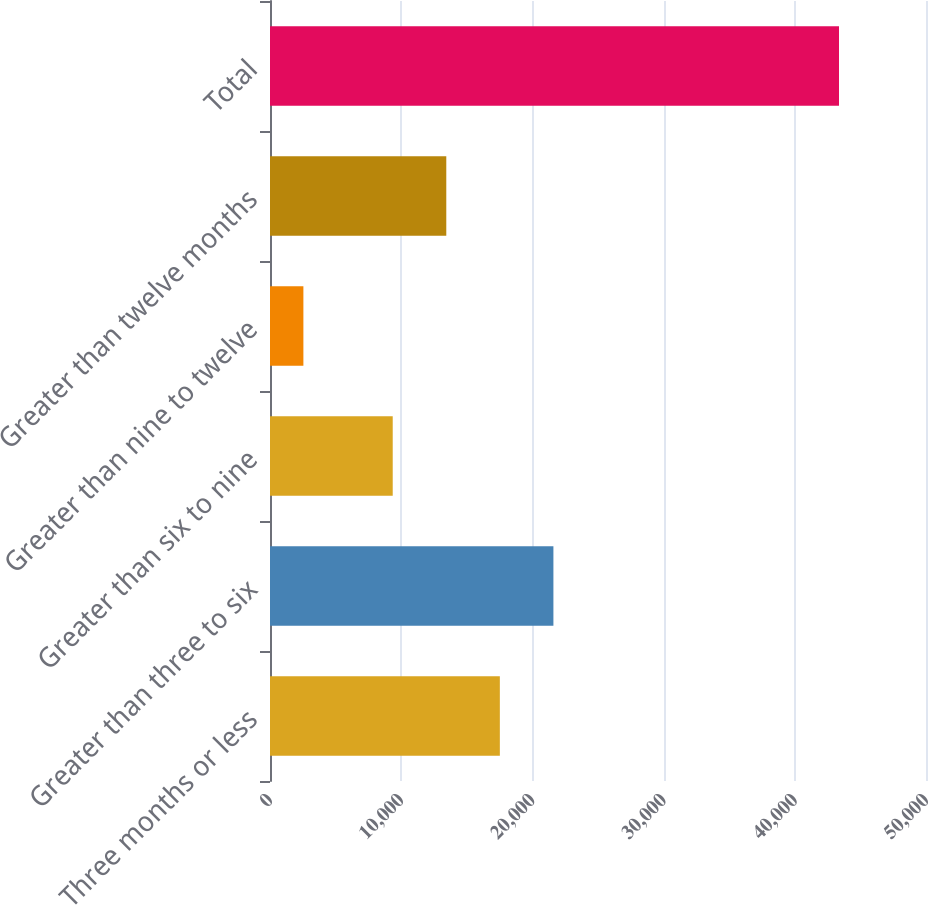Convert chart. <chart><loc_0><loc_0><loc_500><loc_500><bar_chart><fcel>Three months or less<fcel>Greater than three to six<fcel>Greater than six to nine<fcel>Greater than nine to twelve<fcel>Greater than twelve months<fcel>Total<nl><fcel>17518.8<fcel>21601.2<fcel>9354<fcel>2545<fcel>13436.4<fcel>43369<nl></chart> 